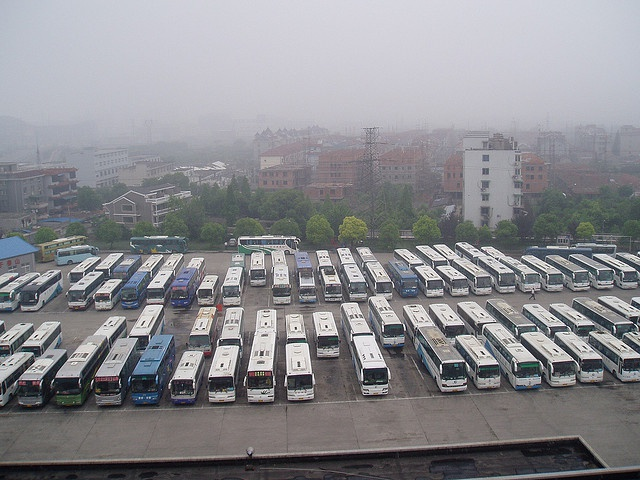Describe the objects in this image and their specific colors. I can see bus in darkgray, gray, lightgray, and black tones, bus in darkgray, black, lightgray, and gray tones, bus in darkgray, black, gray, and lightgray tones, bus in darkgray, lightgray, black, and gray tones, and bus in darkgray, black, gray, and lightgray tones in this image. 